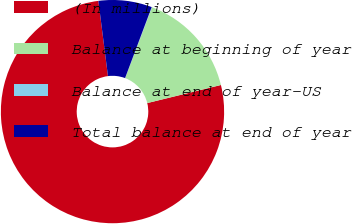Convert chart. <chart><loc_0><loc_0><loc_500><loc_500><pie_chart><fcel>(In millions)<fcel>Balance at beginning of year<fcel>Balance at end of year-US<fcel>Total balance at end of year<nl><fcel>76.81%<fcel>15.41%<fcel>0.05%<fcel>7.73%<nl></chart> 